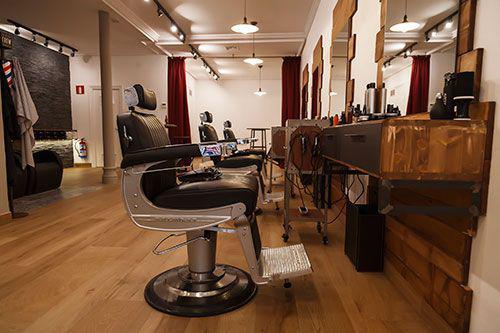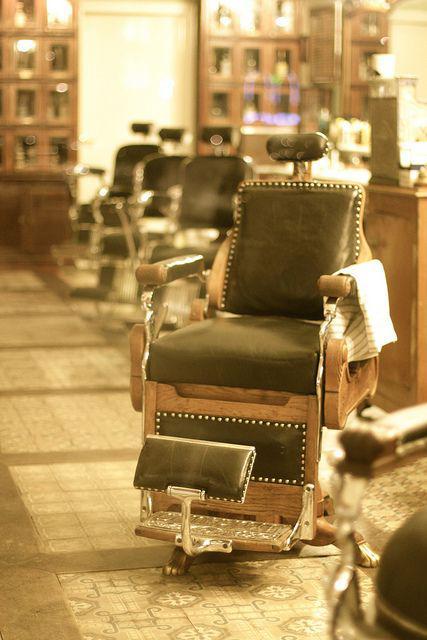The first image is the image on the left, the second image is the image on the right. For the images displayed, is the sentence "There is a barber pole in the image on the left." factually correct? Answer yes or no. No. 